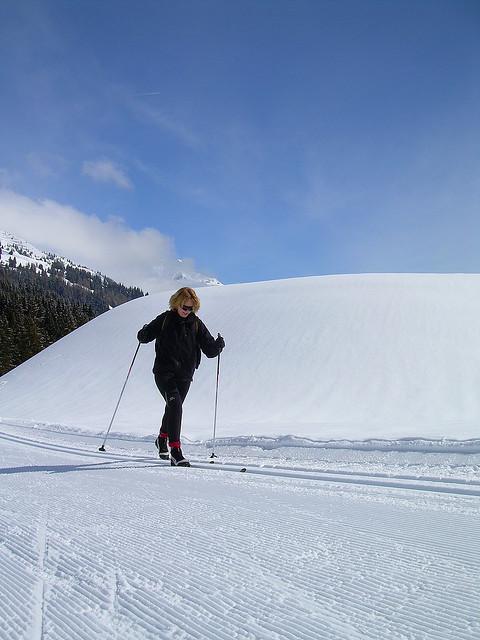Is the rider wearing a helmet?
Keep it brief. No. What color is this person's outfit?
Concise answer only. Black. What time of year is this?
Quick response, please. Winter. How is has the trail been cared for?
Concise answer only. Plowed. What is the woman doing?
Short answer required. Skiing. 